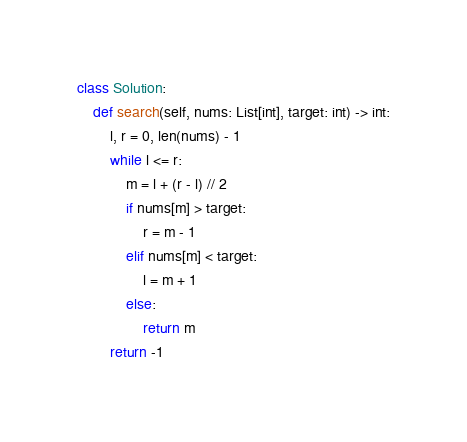<code> <loc_0><loc_0><loc_500><loc_500><_Python_>class Solution:
    def search(self, nums: List[int], target: int) -> int:
        l, r = 0, len(nums) - 1
        while l <= r:
            m = l + (r - l) // 2
            if nums[m] > target:
                r = m - 1
            elif nums[m] < target:
                l = m + 1
            else:
                return m
        return -1
</code> 